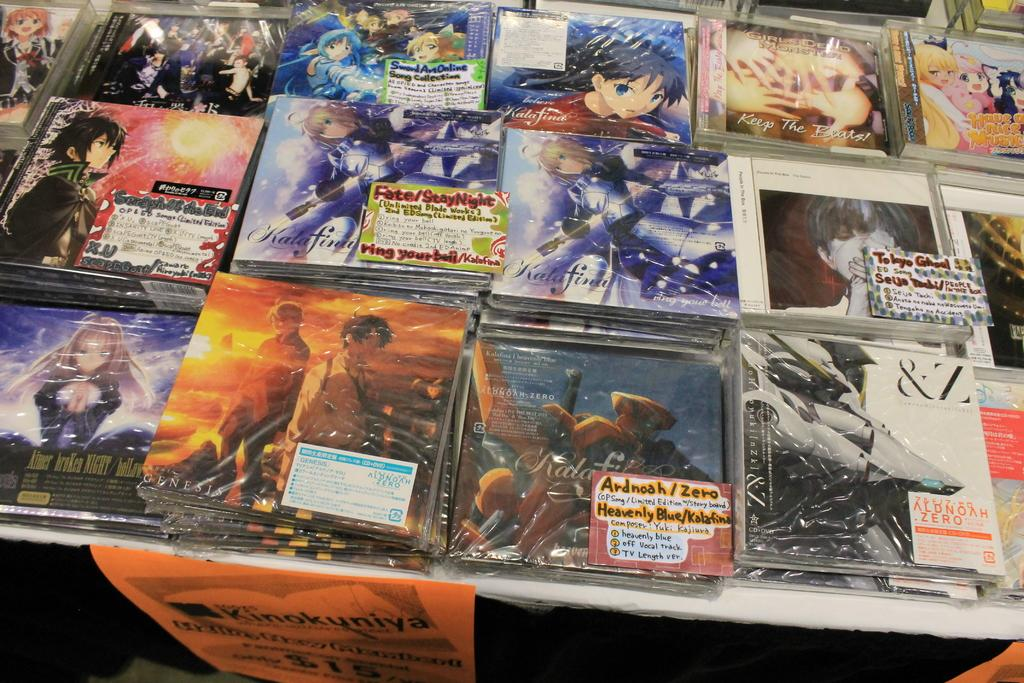<image>
Summarize the visual content of the image. A Keep the Beats CD is on a table with many other CDs. 